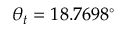<formula> <loc_0><loc_0><loc_500><loc_500>\theta _ { t } = 1 8 . 7 6 9 8 ^ { \circ }</formula> 